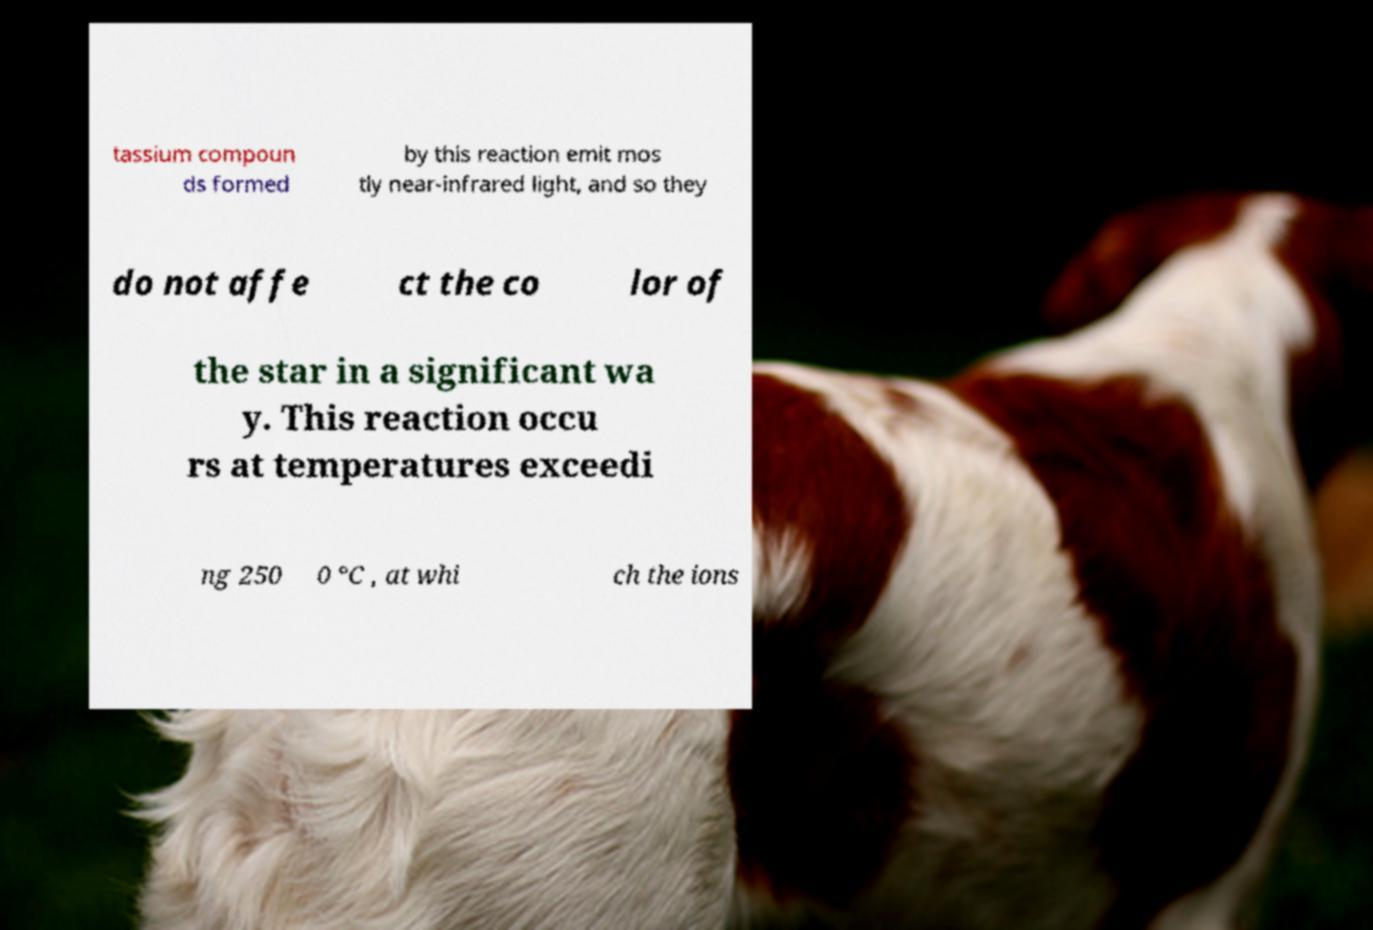I need the written content from this picture converted into text. Can you do that? tassium compoun ds formed by this reaction emit mos tly near-infrared light, and so they do not affe ct the co lor of the star in a significant wa y. This reaction occu rs at temperatures exceedi ng 250 0 °C , at whi ch the ions 